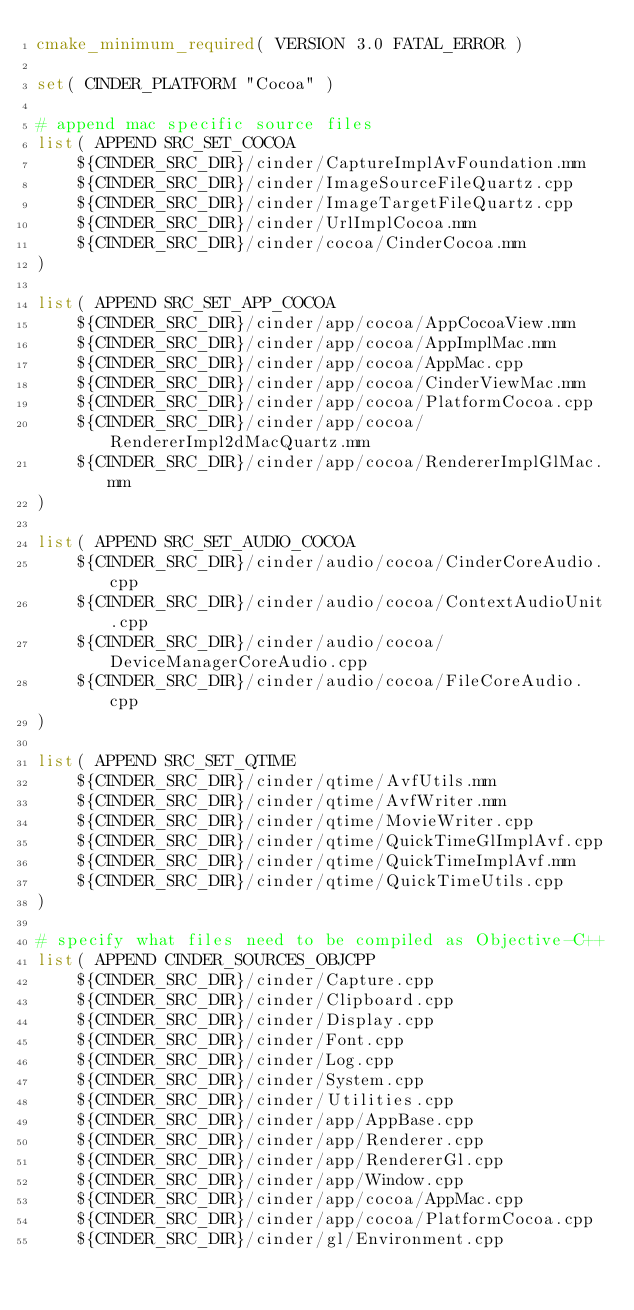<code> <loc_0><loc_0><loc_500><loc_500><_CMake_>cmake_minimum_required( VERSION 3.0 FATAL_ERROR )

set( CINDER_PLATFORM "Cocoa" )

# append mac specific source files
list( APPEND SRC_SET_COCOA
	${CINDER_SRC_DIR}/cinder/CaptureImplAvFoundation.mm
	${CINDER_SRC_DIR}/cinder/ImageSourceFileQuartz.cpp
	${CINDER_SRC_DIR}/cinder/ImageTargetFileQuartz.cpp
	${CINDER_SRC_DIR}/cinder/UrlImplCocoa.mm
	${CINDER_SRC_DIR}/cinder/cocoa/CinderCocoa.mm
)

list( APPEND SRC_SET_APP_COCOA
	${CINDER_SRC_DIR}/cinder/app/cocoa/AppCocoaView.mm
	${CINDER_SRC_DIR}/cinder/app/cocoa/AppImplMac.mm
	${CINDER_SRC_DIR}/cinder/app/cocoa/AppMac.cpp
	${CINDER_SRC_DIR}/cinder/app/cocoa/CinderViewMac.mm
	${CINDER_SRC_DIR}/cinder/app/cocoa/PlatformCocoa.cpp
	${CINDER_SRC_DIR}/cinder/app/cocoa/RendererImpl2dMacQuartz.mm
	${CINDER_SRC_DIR}/cinder/app/cocoa/RendererImplGlMac.mm
)

list( APPEND SRC_SET_AUDIO_COCOA
	${CINDER_SRC_DIR}/cinder/audio/cocoa/CinderCoreAudio.cpp
	${CINDER_SRC_DIR}/cinder/audio/cocoa/ContextAudioUnit.cpp
	${CINDER_SRC_DIR}/cinder/audio/cocoa/DeviceManagerCoreAudio.cpp
	${CINDER_SRC_DIR}/cinder/audio/cocoa/FileCoreAudio.cpp
)

list( APPEND SRC_SET_QTIME
	${CINDER_SRC_DIR}/cinder/qtime/AvfUtils.mm
	${CINDER_SRC_DIR}/cinder/qtime/AvfWriter.mm
	${CINDER_SRC_DIR}/cinder/qtime/MovieWriter.cpp
	${CINDER_SRC_DIR}/cinder/qtime/QuickTimeGlImplAvf.cpp
	${CINDER_SRC_DIR}/cinder/qtime/QuickTimeImplAvf.mm
	${CINDER_SRC_DIR}/cinder/qtime/QuickTimeUtils.cpp
)

# specify what files need to be compiled as Objective-C++
list( APPEND CINDER_SOURCES_OBJCPP
	${CINDER_SRC_DIR}/cinder/Capture.cpp
	${CINDER_SRC_DIR}/cinder/Clipboard.cpp
	${CINDER_SRC_DIR}/cinder/Display.cpp
	${CINDER_SRC_DIR}/cinder/Font.cpp
	${CINDER_SRC_DIR}/cinder/Log.cpp
	${CINDER_SRC_DIR}/cinder/System.cpp
	${CINDER_SRC_DIR}/cinder/Utilities.cpp
	${CINDER_SRC_DIR}/cinder/app/AppBase.cpp
	${CINDER_SRC_DIR}/cinder/app/Renderer.cpp
	${CINDER_SRC_DIR}/cinder/app/RendererGl.cpp
	${CINDER_SRC_DIR}/cinder/app/Window.cpp
	${CINDER_SRC_DIR}/cinder/app/cocoa/AppMac.cpp
	${CINDER_SRC_DIR}/cinder/app/cocoa/PlatformCocoa.cpp
	${CINDER_SRC_DIR}/cinder/gl/Environment.cpp</code> 